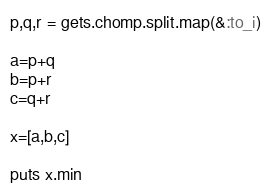<code> <loc_0><loc_0><loc_500><loc_500><_Ruby_>p,q,r = gets.chomp.split.map(&:to_i)

a=p+q
b=p+r
c=q+r

x=[a,b,c]

puts x.min
</code> 